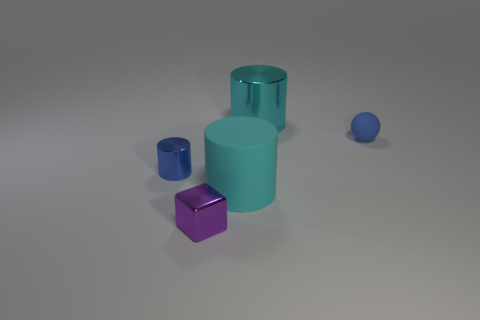If this image was part of a product advertisement, what characteristics might it be highlighting? If this image was part of a product advertisement, it might be highlighting the sleek and modern design of the objects, their calming cyan color palette, and the clean lines that give these items a minimalist aesthetic. 